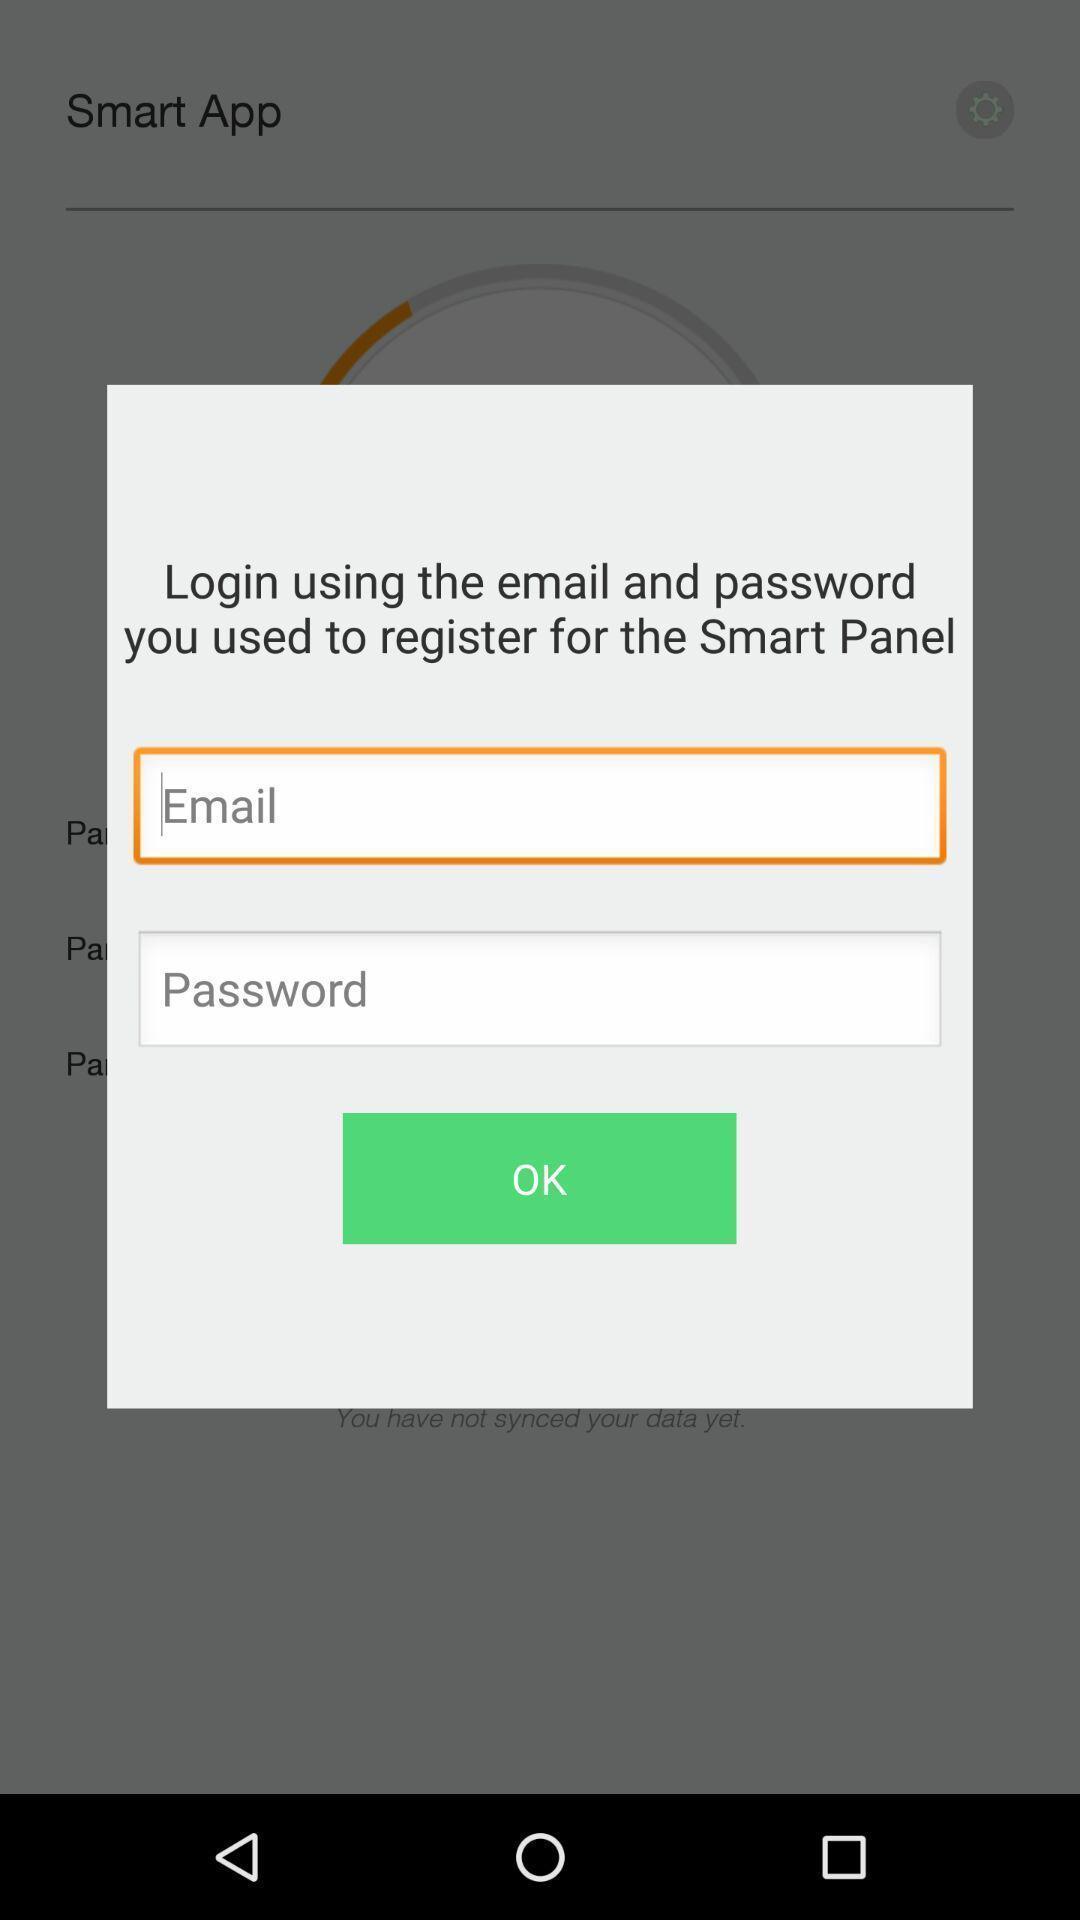What is the overall content of this screenshot? Popup displaying signing in information about an application. 